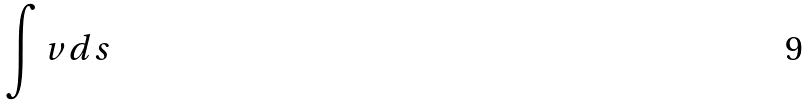<formula> <loc_0><loc_0><loc_500><loc_500>\int v d s</formula> 